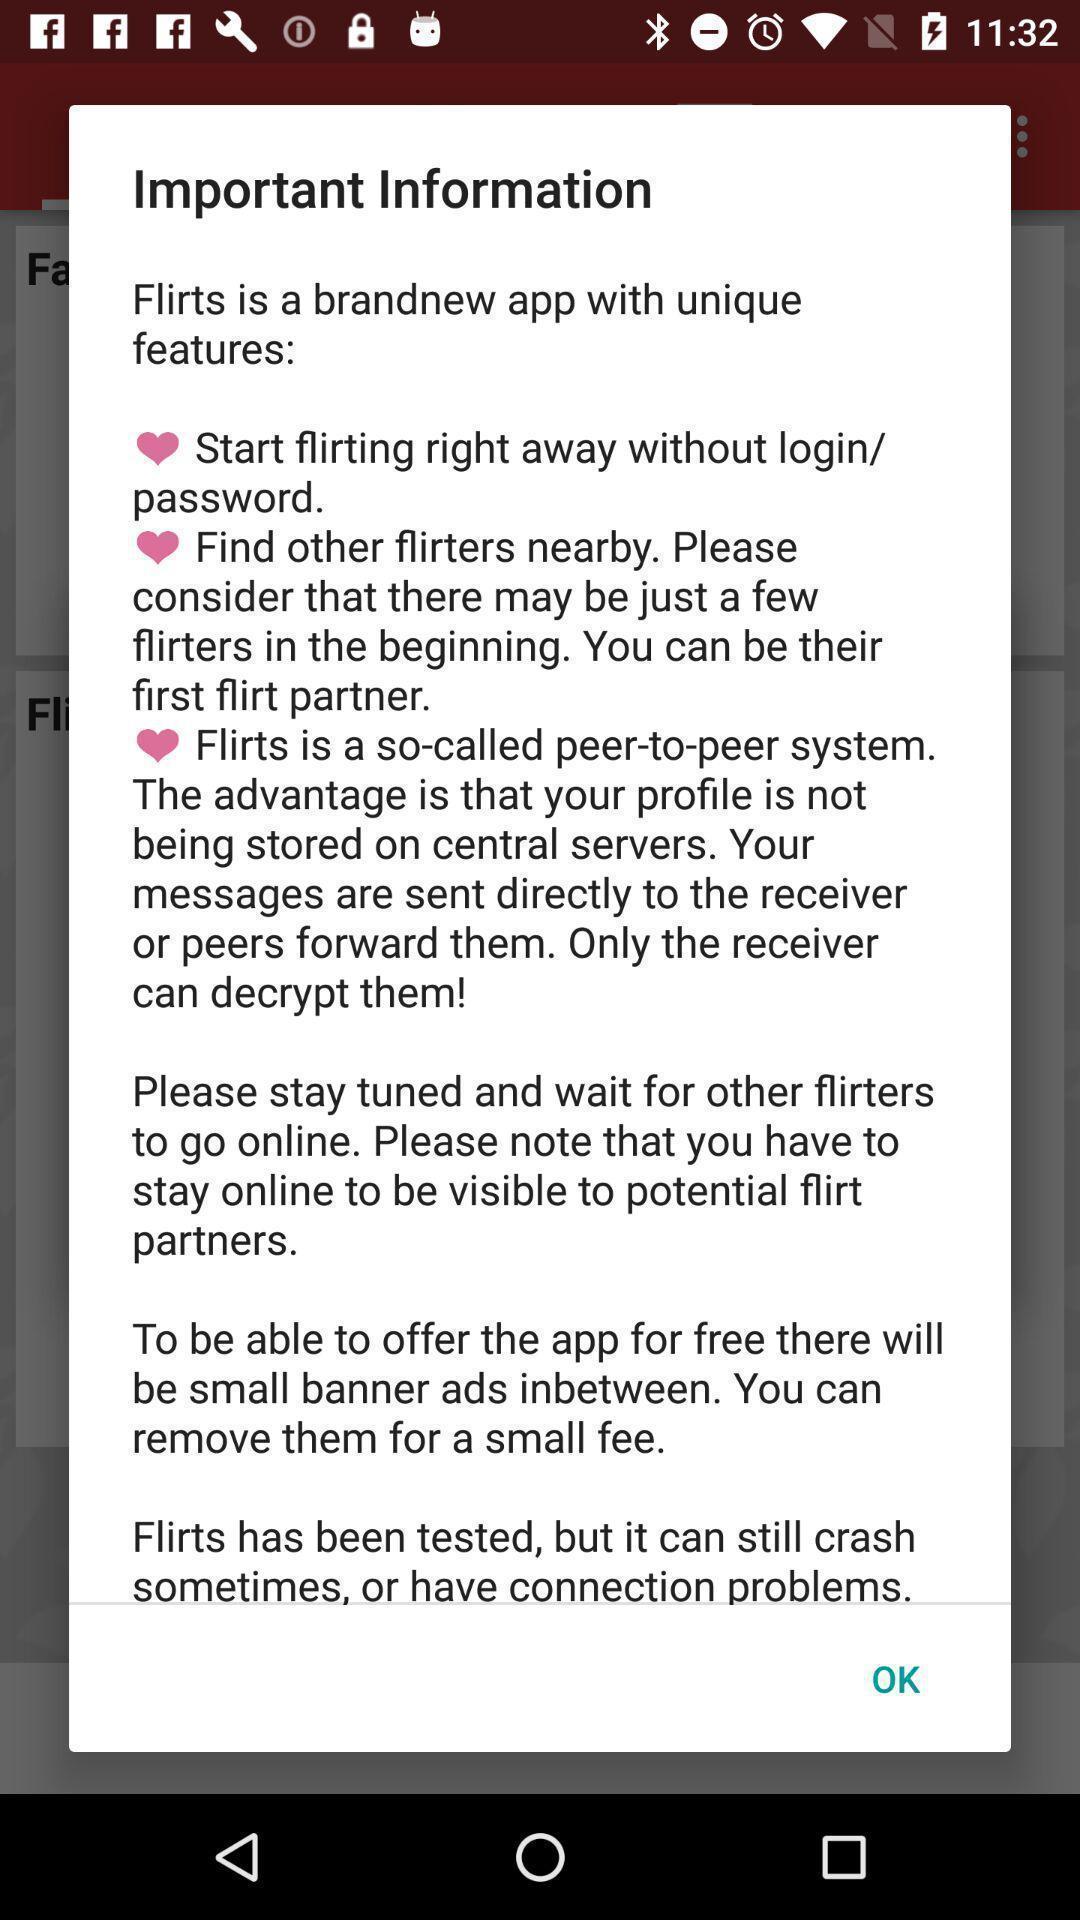Describe this image in words. Pop-up window is showing information related to app. 